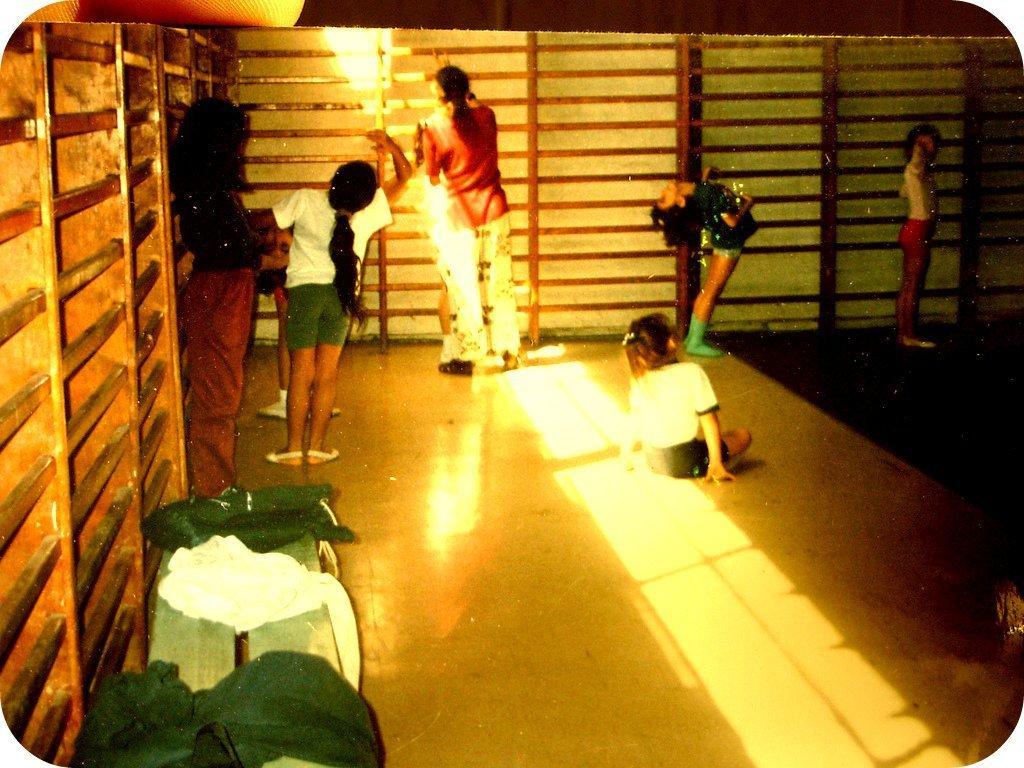Please provide a concise description of this image. In this picture I can see a few people standing on the surface. I can see the wooden grill fence. 